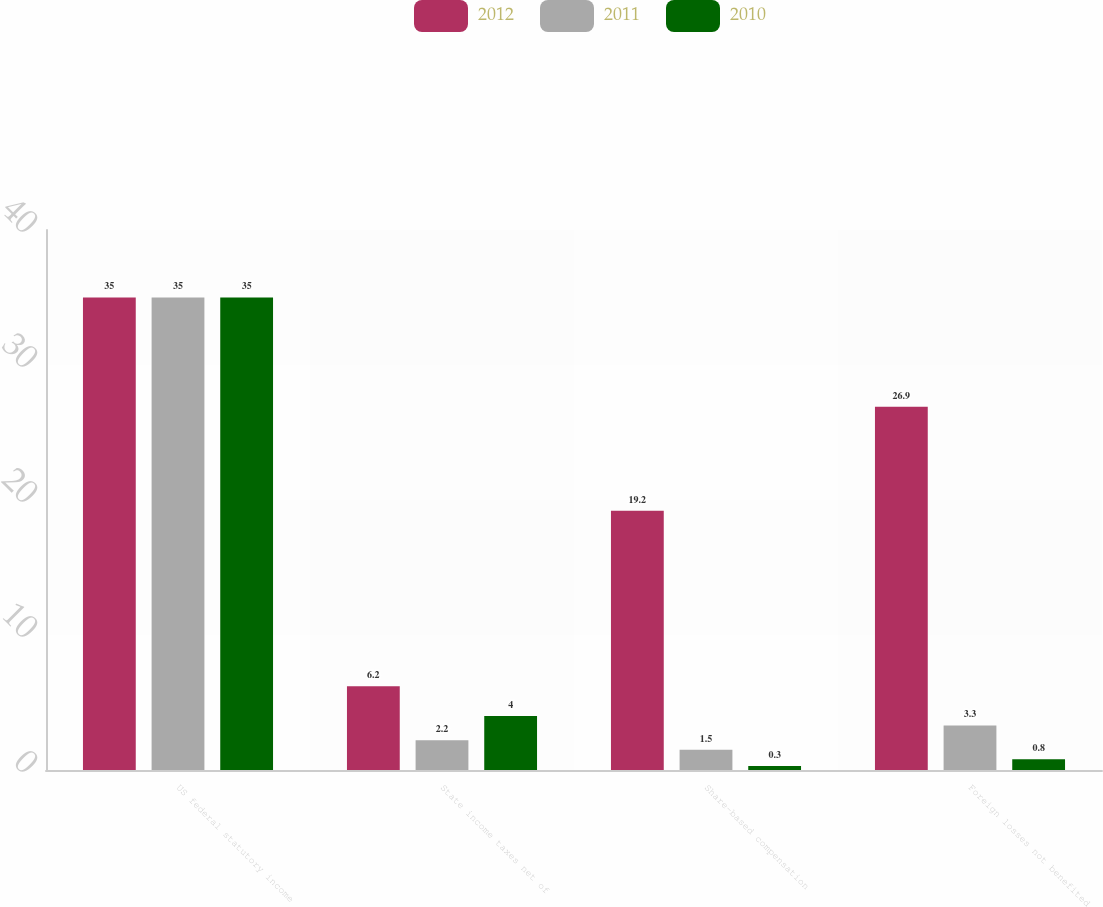Convert chart. <chart><loc_0><loc_0><loc_500><loc_500><stacked_bar_chart><ecel><fcel>US federal statutory income<fcel>State income taxes net of<fcel>Share-based compensation<fcel>Foreign losses not benefited<nl><fcel>2012<fcel>35<fcel>6.2<fcel>19.2<fcel>26.9<nl><fcel>2011<fcel>35<fcel>2.2<fcel>1.5<fcel>3.3<nl><fcel>2010<fcel>35<fcel>4<fcel>0.3<fcel>0.8<nl></chart> 